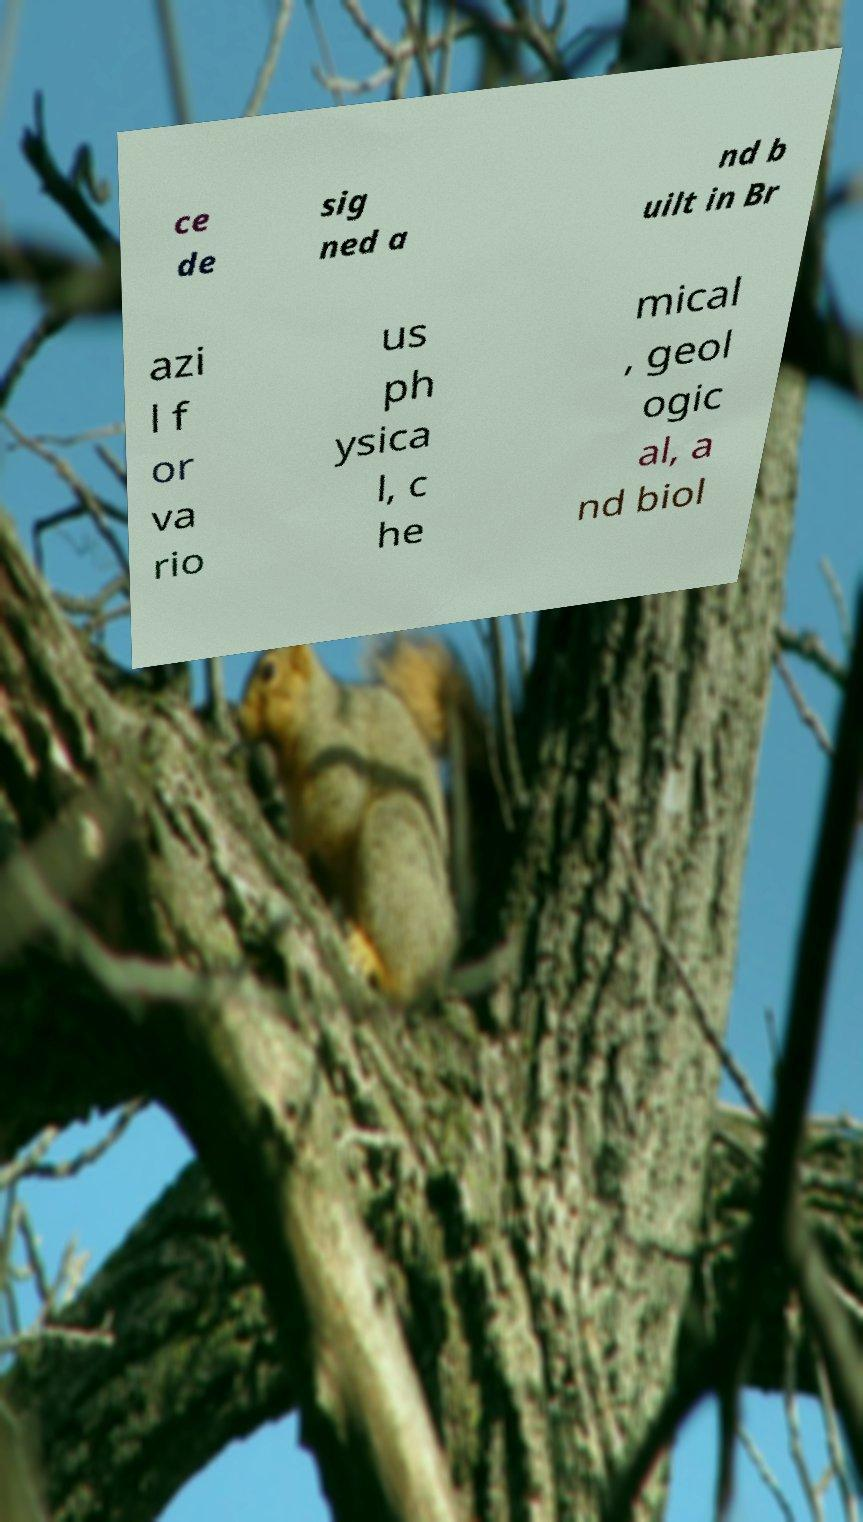Please identify and transcribe the text found in this image. ce de sig ned a nd b uilt in Br azi l f or va rio us ph ysica l, c he mical , geol ogic al, a nd biol 